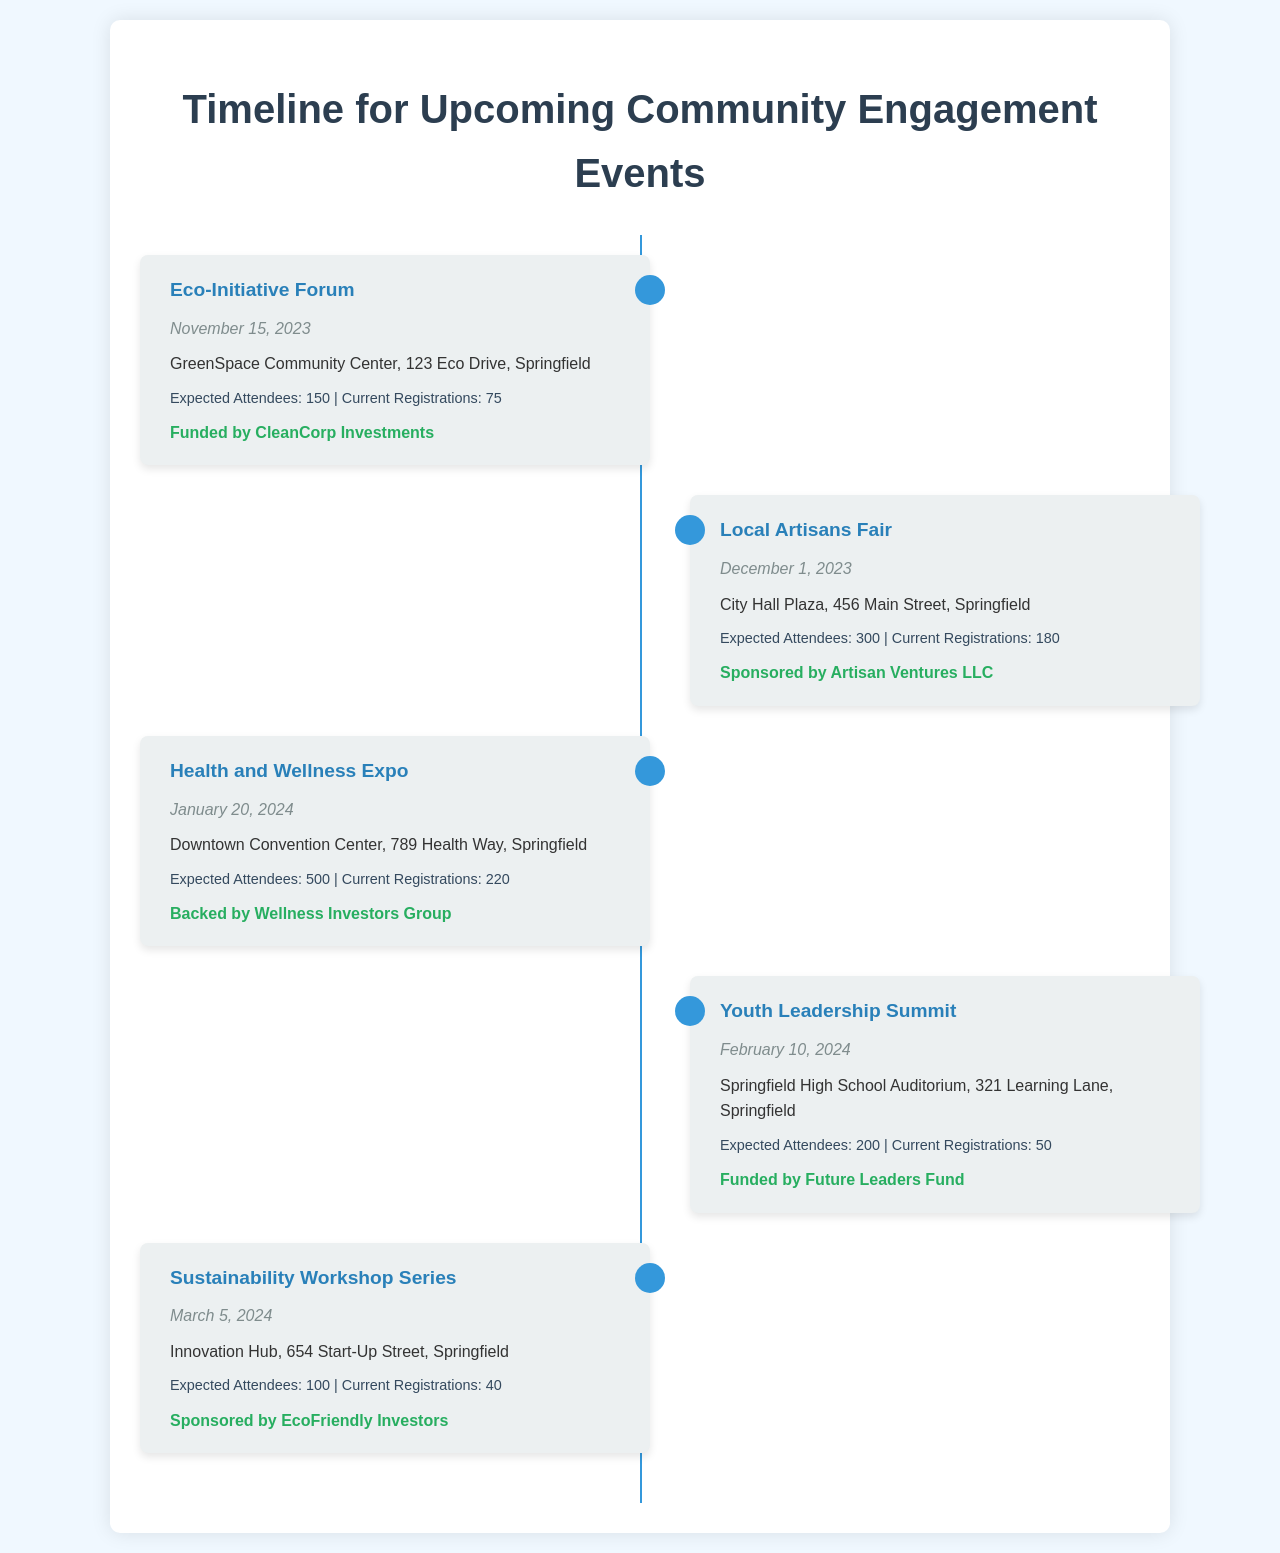What is the date of the Eco-Initiative Forum? The date is stated clearly in the event details for the Eco-Initiative Forum.
Answer: November 15, 2023 Where is the Local Artisans Fair being held? The venue is provided for the Local Artisans Fair under its details.
Answer: City Hall Plaza, 456 Main Street, Springfield How many expected attendees are there for the Health and Wellness Expo? The expected number of attendees is given in the metrics for the Health and Wellness Expo.
Answer: 500 Which event has the least current registrations? To determine this, we need to compare the current registrations of all events.
Answer: Youth Leadership Summit Who is sponsoring the Sustainability Workshop Series? The sponsor's name is mentioned in the investor support section for the Sustainability Workshop Series.
Answer: EcoFriendly Investors 